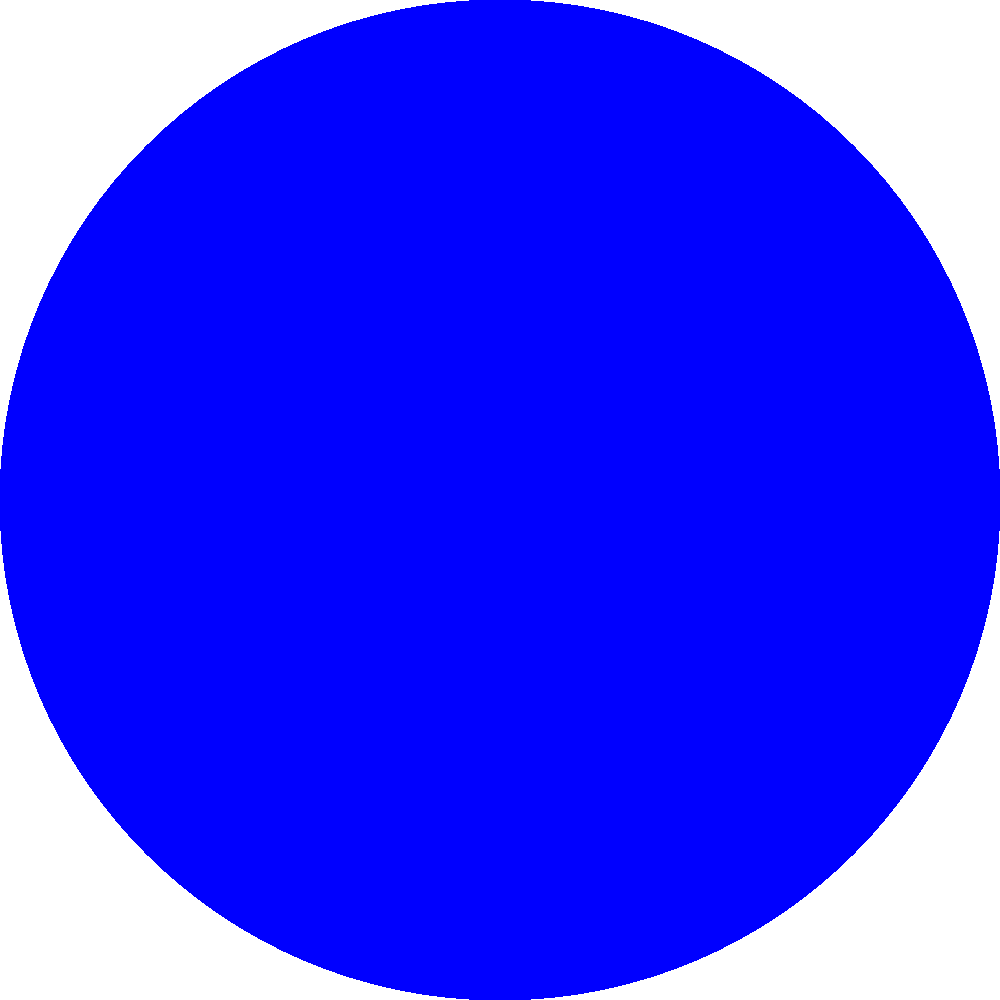As a web developer familiar with templating engines like Twig, you understand the importance of organizing and displaying data efficiently. Similarly, the Moon's phases follow a predictable pattern. Based on the diagram, which phase would occur approximately one week after the New Moon, and what percentage of the Moon's visible surface would be illuminated from Earth's perspective? To answer this question, let's break it down step-by-step:

1. The diagram shows four main phases of the Moon: New Moon, First Quarter, Full Moon, and Last Quarter.

2. The Moon's phases progress in a cyclical manner, moving from New Moon to Full Moon and back to New Moon over approximately 29.5 days (one lunar month).

3. The order of phases shown in the diagram, from top to bottom, represents the chronological order of the Moon's phases as seen from Earth.

4. One week is approximately 1/4 of a lunar month.

5. Starting from the New Moon (top of the diagram), moving one phase down brings us to the First Quarter Moon.

6. At First Quarter, we can see that exactly half of the Moon's visible surface is illuminated (the right half of the Moon's disk).

7. To calculate the percentage of the Moon's visible surface that is illuminated:
   $\text{Percentage} = \frac{\text{Illuminated area}}{\text{Total visible area}} \times 100\%$
   $= \frac{1/2}{1} \times 100\% = 50\%$

Therefore, approximately one week after the New Moon, the Moon would be in its First Quarter phase, with 50% of its visible surface illuminated from Earth's perspective.
Answer: First Quarter, 50% illuminated 